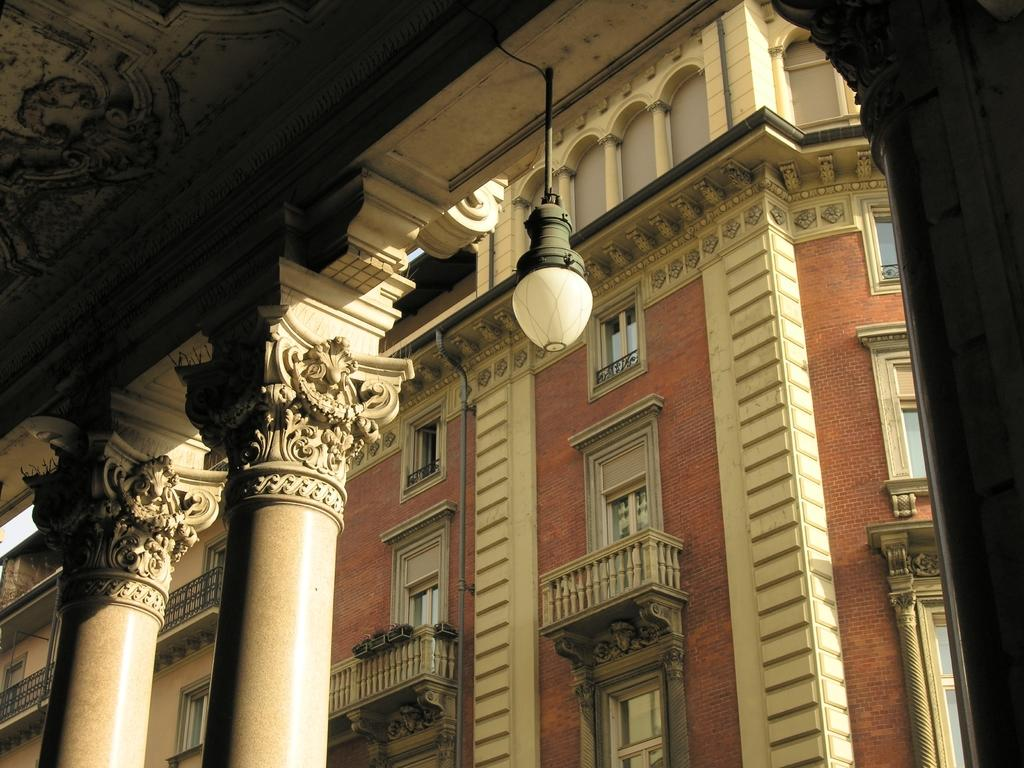What type of structures are present in the image? There are buildings in the image. What feature can be seen on the buildings? The buildings have windows. What architectural element is visible on the left side of the image? There are pillars on the left side of the image. What source of illumination is present in the image? There is a light in the image. What is the opinion of the children about the buildings in the image? There are no children present in the image, so their opinions cannot be determined. 